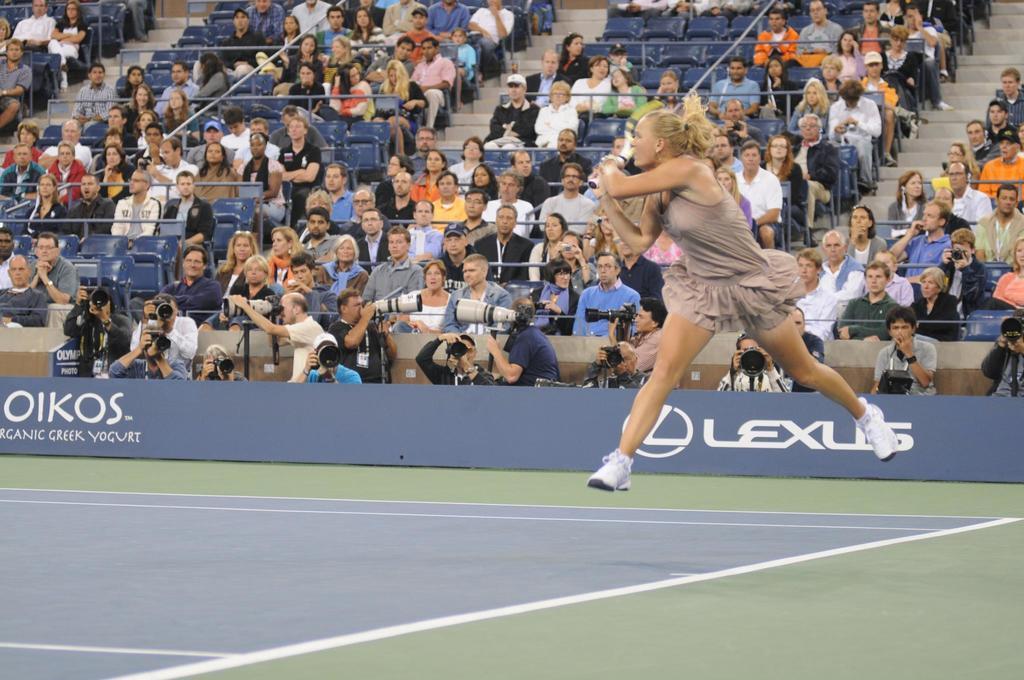Describe this image in one or two sentences. a person is playing tennis, holding a racket in her hand. behind her people are seated on the chairs watching her. below them in the front there are cameramen 